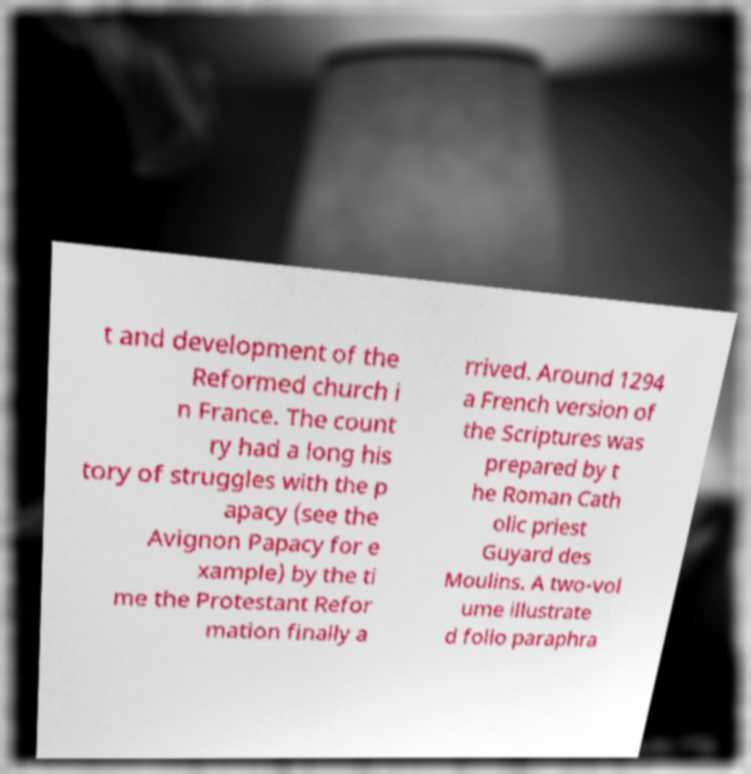Can you accurately transcribe the text from the provided image for me? t and development of the Reformed church i n France. The count ry had a long his tory of struggles with the p apacy (see the Avignon Papacy for e xample) by the ti me the Protestant Refor mation finally a rrived. Around 1294 a French version of the Scriptures was prepared by t he Roman Cath olic priest Guyard des Moulins. A two-vol ume illustrate d folio paraphra 